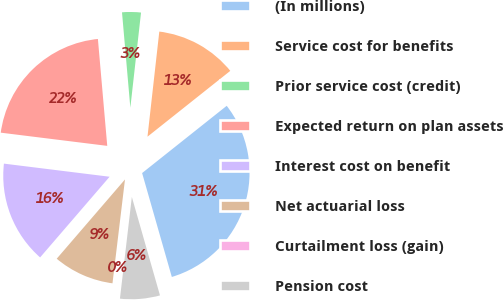Convert chart. <chart><loc_0><loc_0><loc_500><loc_500><pie_chart><fcel>(In millions)<fcel>Service cost for benefits<fcel>Prior service cost (credit)<fcel>Expected return on plan assets<fcel>Interest cost on benefit<fcel>Net actuarial loss<fcel>Curtailment loss (gain)<fcel>Pension cost<nl><fcel>31.26%<fcel>12.53%<fcel>3.17%<fcel>21.65%<fcel>15.65%<fcel>9.41%<fcel>0.05%<fcel>6.29%<nl></chart> 